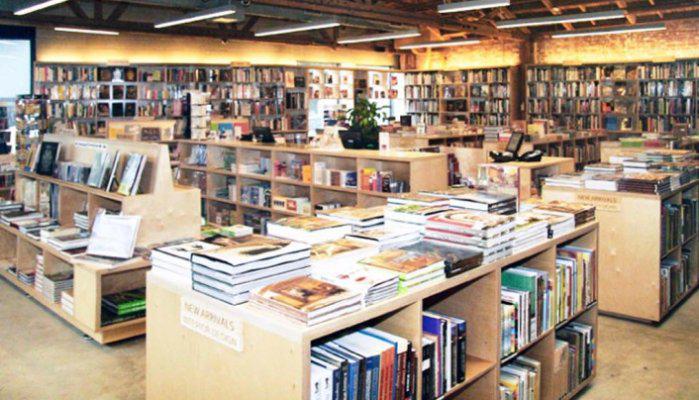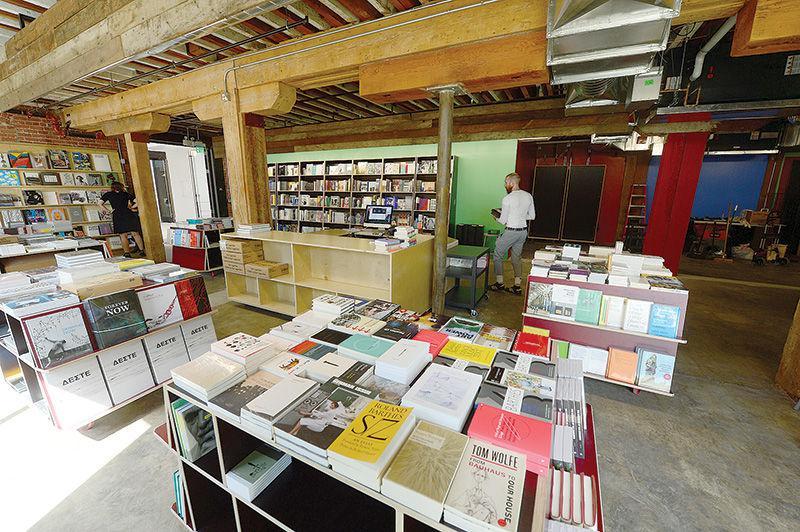The first image is the image on the left, the second image is the image on the right. Analyze the images presented: Is the assertion "There are banks of fluorescent lights visible in at least one of the images." valid? Answer yes or no. Yes. The first image is the image on the left, the second image is the image on the right. Assess this claim about the two images: "The right image shows a bookstore interior with T-shaped wooden support beams in front of a green wall and behind freestanding displays of books.". Correct or not? Answer yes or no. Yes. 